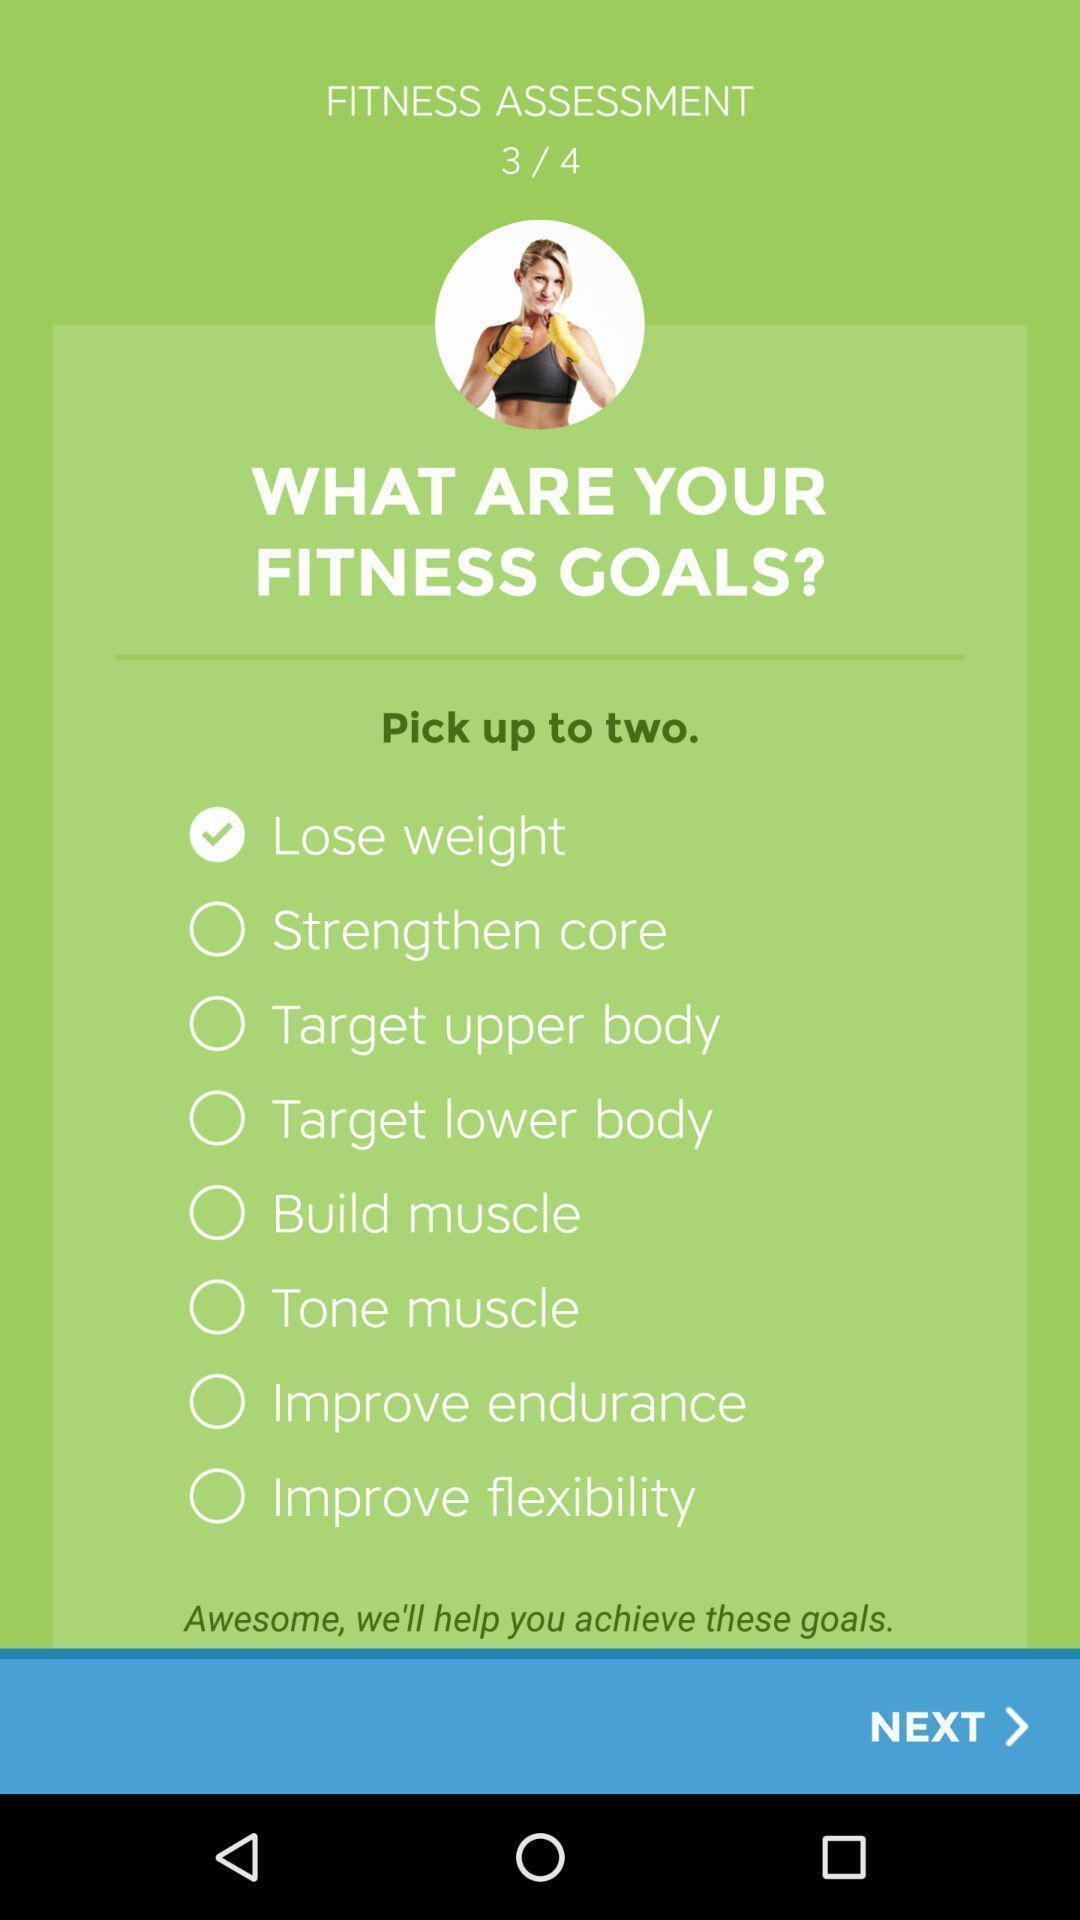Summarize the information in this screenshot. Page displays to pick fitness goals. 